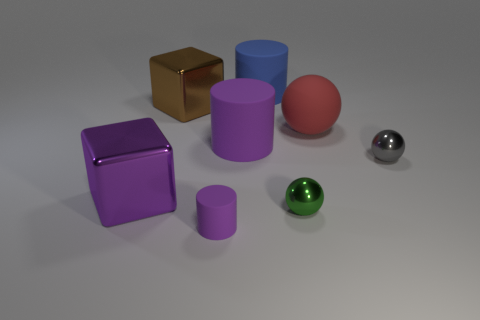Can you describe the different materials depicted in the objects shown? Sure! In the image, there are objects with various materials and finishes. The cube towards the back appears to be gold and has a reflective metallic surface. A large blue cylinder seems to have a matte surface, while the pink sphere and the smaller silver sphere have a shiny, reflective surface indicative of a glossy, possibly metallic, finish. Similarly, the purple cube and cylinder have a smooth yet non-reflective surface suggesting a solid matte finish. 